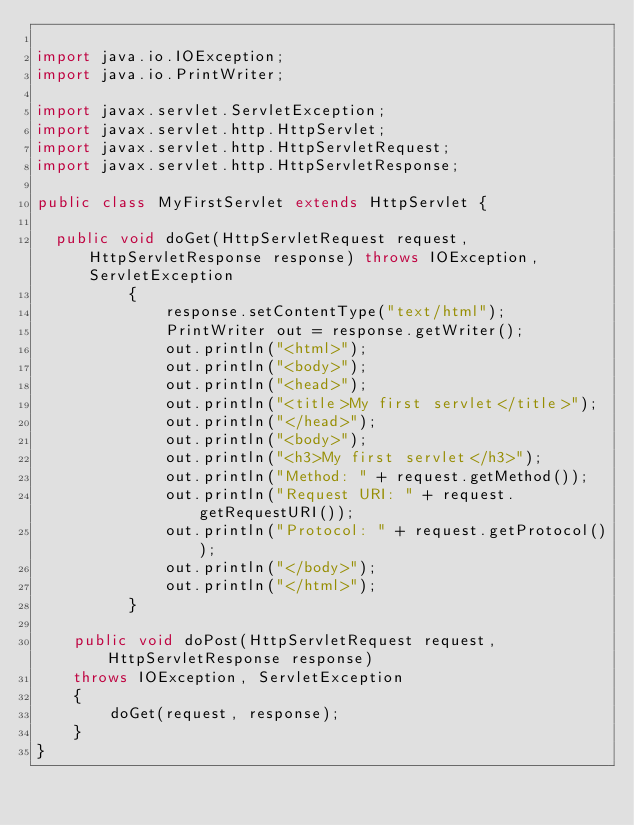Convert code to text. <code><loc_0><loc_0><loc_500><loc_500><_Java_>
import java.io.IOException;
import java.io.PrintWriter;

import javax.servlet.ServletException;
import javax.servlet.http.HttpServlet;
import javax.servlet.http.HttpServletRequest;
import javax.servlet.http.HttpServletResponse;

public class MyFirstServlet extends HttpServlet {

	public void doGet(HttpServletRequest request, HttpServletResponse response) throws IOException, ServletException
			    {
			        response.setContentType("text/html");
			        PrintWriter out = response.getWriter();
			        out.println("<html>");
			        out.println("<body>");
			        out.println("<head>");
			        out.println("<title>My first servlet</title>");
			        out.println("</head>");
			        out.println("<body>");
			        out.println("<h3>My first servlet</h3>");
			        out.println("Method: " + request.getMethod());
			        out.println("Request URI: " + request.getRequestURI());
			        out.println("Protocol: " + request.getProtocol());
			        out.println("</body>");
			        out.println("</html>");
			    }

    public void doPost(HttpServletRequest request, HttpServletResponse response)
    throws IOException, ServletException
    {
        doGet(request, response);
    }
}
</code> 